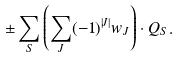Convert formula to latex. <formula><loc_0><loc_0><loc_500><loc_500>\pm \sum _ { S } \left ( \sum _ { J } ( - 1 ) ^ { | J | } w _ { J } \right ) \cdot Q _ { S } .</formula> 